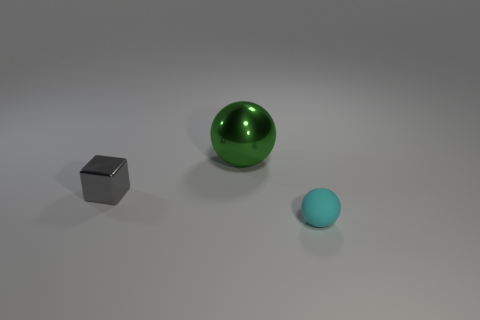What color is the thing that is in front of the gray thing?
Provide a succinct answer. Cyan. What is the shape of the object that is in front of the big green metallic thing and behind the small rubber ball?
Offer a terse response. Cube. What number of other green metal things are the same shape as the green object?
Offer a very short reply. 0. What number of large balls are there?
Your answer should be compact. 1. There is a thing that is both in front of the big green ball and behind the tiny ball; how big is it?
Offer a terse response. Small. What is the shape of the shiny object that is the same size as the cyan rubber ball?
Provide a short and direct response. Cube. There is a ball on the right side of the large metal thing; are there any tiny gray metallic cubes right of it?
Keep it short and to the point. No. The metallic object that is the same shape as the small cyan matte thing is what color?
Give a very brief answer. Green. There is a small thing behind the cyan sphere; does it have the same color as the small rubber object?
Give a very brief answer. No. What number of things are shiny things that are behind the gray object or small red rubber objects?
Provide a succinct answer. 1. 